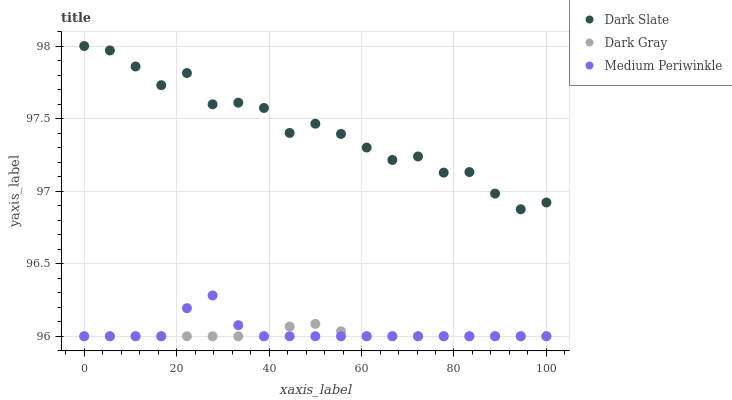Does Dark Gray have the minimum area under the curve?
Answer yes or no. Yes. Does Dark Slate have the maximum area under the curve?
Answer yes or no. Yes. Does Medium Periwinkle have the minimum area under the curve?
Answer yes or no. No. Does Medium Periwinkle have the maximum area under the curve?
Answer yes or no. No. Is Dark Gray the smoothest?
Answer yes or no. Yes. Is Dark Slate the roughest?
Answer yes or no. Yes. Is Medium Periwinkle the smoothest?
Answer yes or no. No. Is Medium Periwinkle the roughest?
Answer yes or no. No. Does Dark Gray have the lowest value?
Answer yes or no. Yes. Does Dark Slate have the lowest value?
Answer yes or no. No. Does Dark Slate have the highest value?
Answer yes or no. Yes. Does Medium Periwinkle have the highest value?
Answer yes or no. No. Is Dark Gray less than Dark Slate?
Answer yes or no. Yes. Is Dark Slate greater than Dark Gray?
Answer yes or no. Yes. Does Medium Periwinkle intersect Dark Gray?
Answer yes or no. Yes. Is Medium Periwinkle less than Dark Gray?
Answer yes or no. No. Is Medium Periwinkle greater than Dark Gray?
Answer yes or no. No. Does Dark Gray intersect Dark Slate?
Answer yes or no. No. 